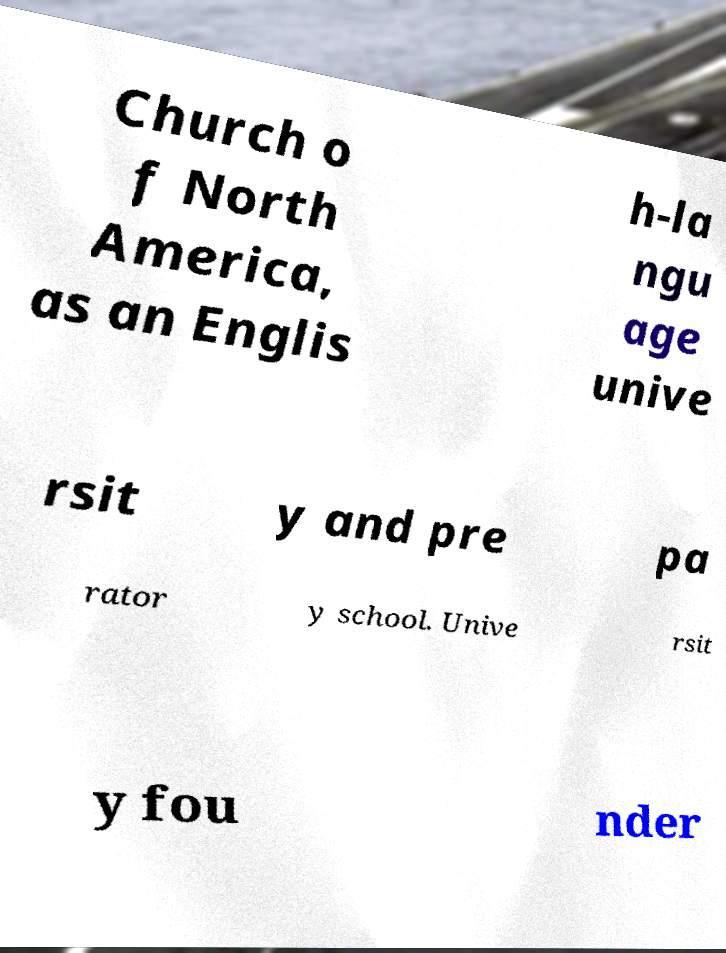Please identify and transcribe the text found in this image. Church o f North America, as an Englis h-la ngu age unive rsit y and pre pa rator y school. Unive rsit y fou nder 